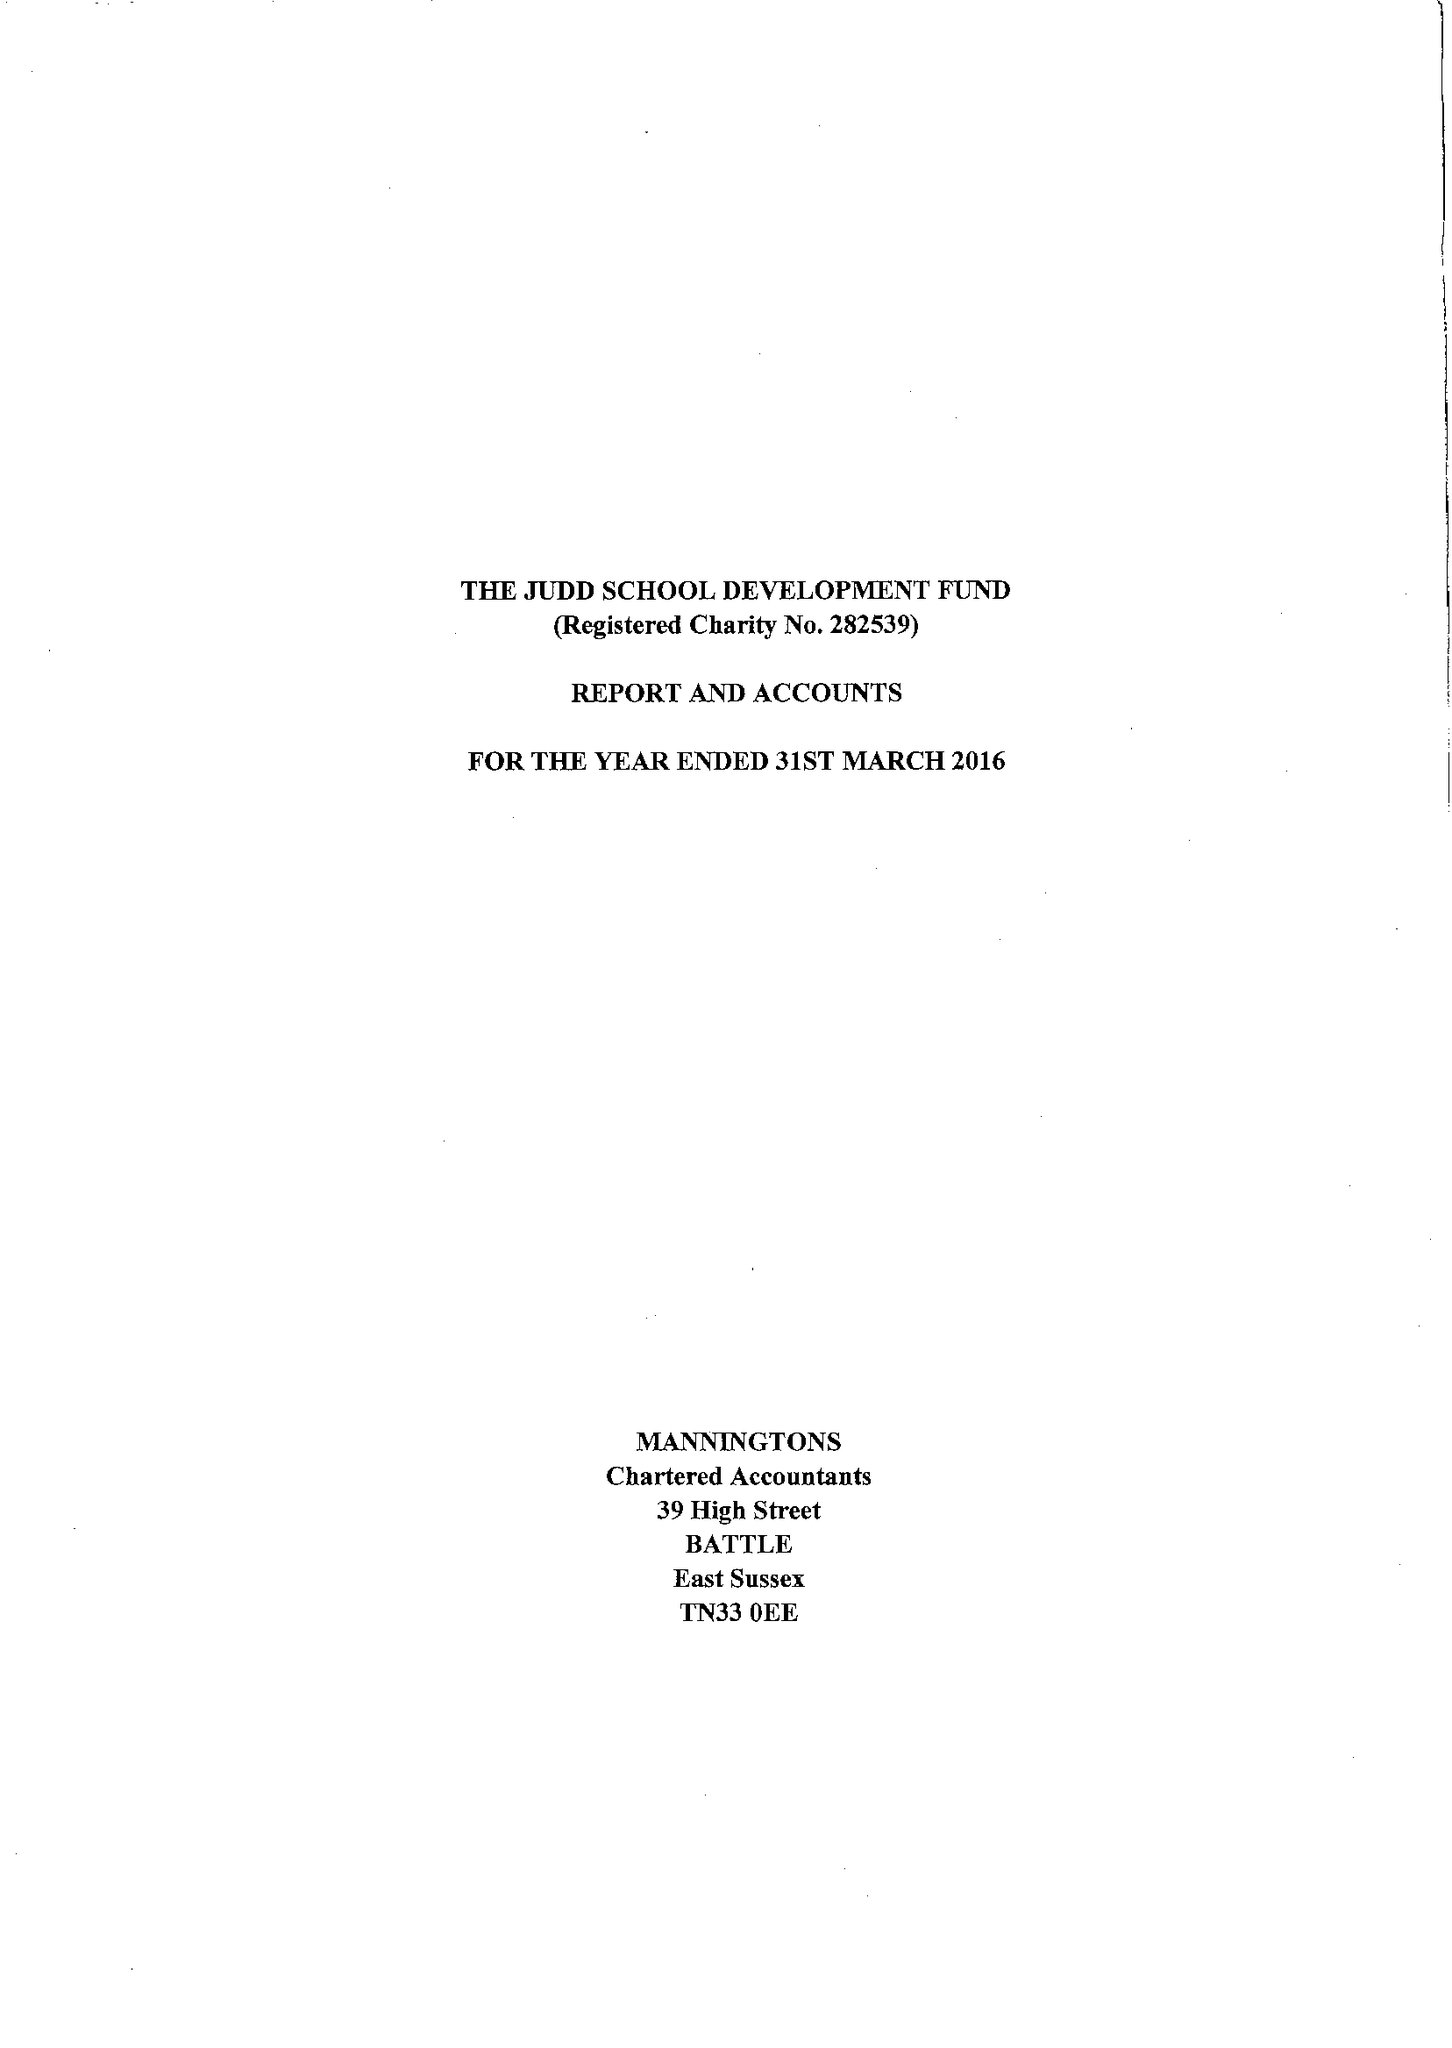What is the value for the income_annually_in_british_pounds?
Answer the question using a single word or phrase. 278800.00 